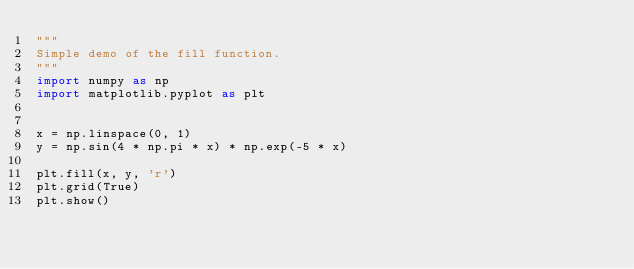Convert code to text. <code><loc_0><loc_0><loc_500><loc_500><_Python_>"""
Simple demo of the fill function.
"""
import numpy as np
import matplotlib.pyplot as plt


x = np.linspace(0, 1)
y = np.sin(4 * np.pi * x) * np.exp(-5 * x)

plt.fill(x, y, 'r')
plt.grid(True)
plt.show()
</code> 